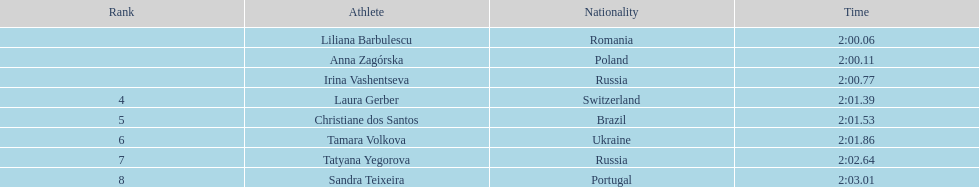What was anna zagorska's completion time? 2:00.11. 